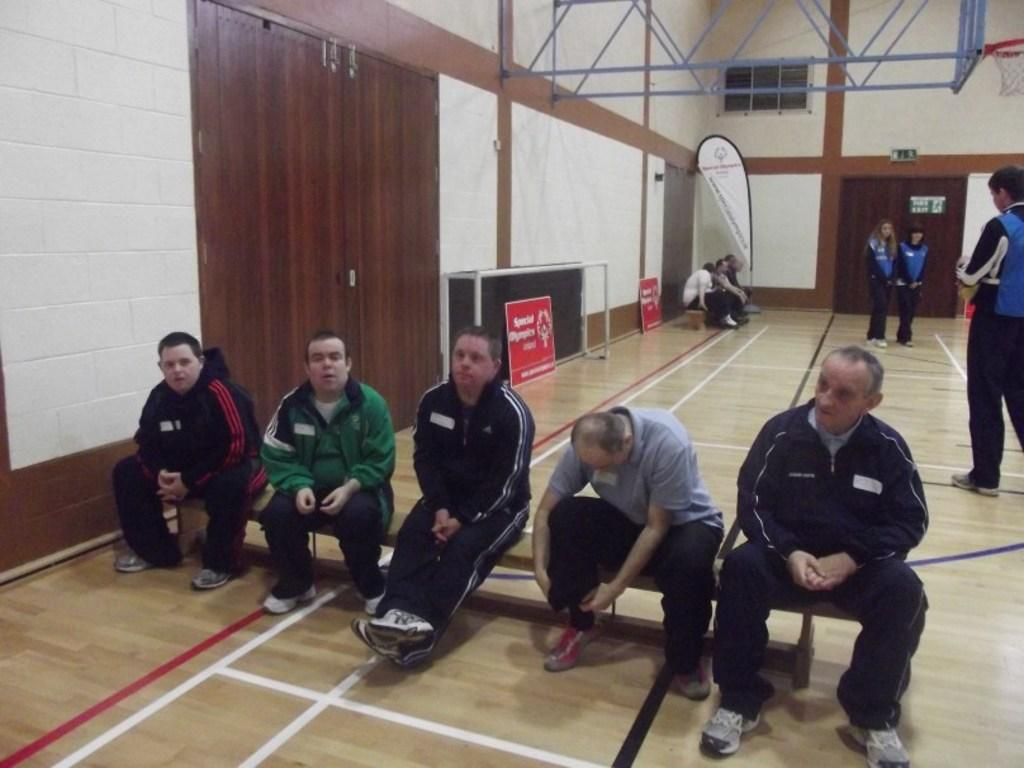What are the people in the image doing? There is a group of persons sitting on a bench in the image. What can be seen in the background of the image? There is a door, persons, a ventilator, iron rods, and a wall in the background. What type of root can be seen growing from the ventilator in the image? There is no root growing from the ventilator in the image. Can you tell me how many fangs are visible on the persons sitting on the bench? There are no fangs visible on the persons sitting on the bench in the image. 